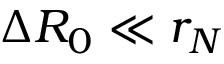Convert formula to latex. <formula><loc_0><loc_0><loc_500><loc_500>\Delta R _ { 0 } \ll r _ { N }</formula> 